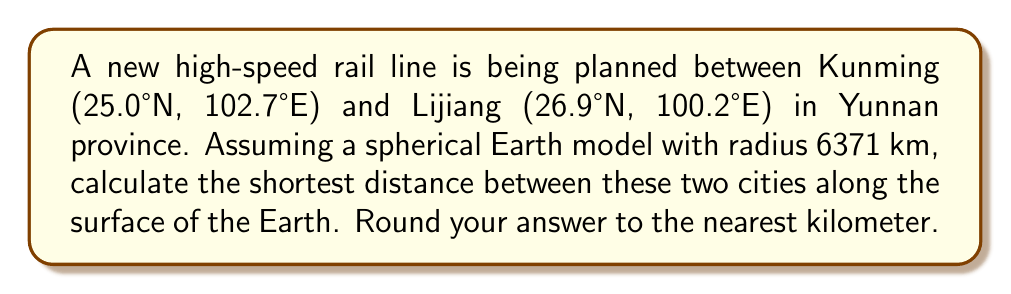Solve this math problem. To solve this problem, we'll use the great circle distance formula, which gives the shortest path between two points on a sphere. The steps are as follows:

1) Convert the latitudes and longitudes to radians:
   Kunming: $\phi_1 = 25.0° \times \frac{\pi}{180} = 0.4363$ rad, $\lambda_1 = 102.7° \times \frac{\pi}{180} = 1.7925$ rad
   Lijiang: $\phi_2 = 26.9° \times \frac{\pi}{180} = 0.4695$ rad, $\lambda_2 = 100.2° \times \frac{\pi}{180} = 1.7488$ rad

2) Calculate the central angle $\Delta\sigma$ using the Haversine formula:
   $$\Delta\sigma = 2 \arcsin\left(\sqrt{\sin^2\left(\frac{\phi_2 - \phi_1}{2}\right) + \cos\phi_1 \cos\phi_2 \sin^2\left(\frac{\lambda_2 - \lambda_1}{2}\right)}\right)$$

3) Substitute the values:
   $$\Delta\sigma = 2 \arcsin\left(\sqrt{\sin^2\left(\frac{0.4695 - 0.4363}{2}\right) + \cos(0.4363) \cos(0.4695) \sin^2\left(\frac{1.7488 - 1.7925}{2}\right)}\right)$$

4) Calculate:
   $$\Delta\sigma = 2 \arcsin(\sqrt{0.000275 + 0.746814 \times 0.000600}) = 0.0461 \text{ rad}$$

5) The distance $d$ is then given by:
   $$d = R \Delta\sigma$$
   where $R$ is the radius of the Earth (6371 km).

6) Calculate the final distance:
   $$d = 6371 \times 0.0461 = 293.7 \text{ km}$$

7) Rounding to the nearest kilometer:
   $$d \approx 294 \text{ km}$$
Answer: 294 km 